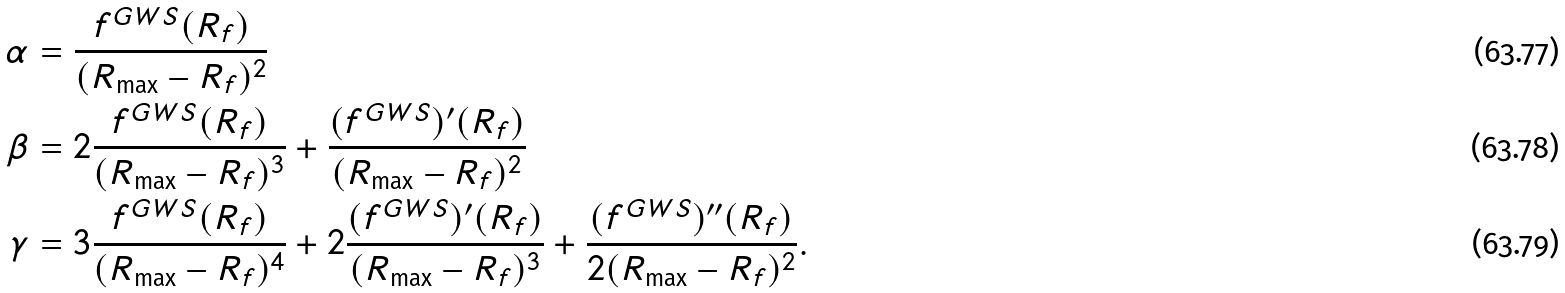Convert formula to latex. <formula><loc_0><loc_0><loc_500><loc_500>\alpha & = \frac { f ^ { G W S } ( R _ { f } ) } { ( R _ { \max } - R _ { f } ) ^ { 2 } } \\ \beta & = 2 \frac { f ^ { G W S } ( R _ { f } ) } { ( R _ { \max } - R _ { f } ) ^ { 3 } } + \frac { ( f ^ { G W S } ) ^ { \prime } ( R _ { f } ) } { ( R _ { \max } - R _ { f } ) ^ { 2 } } \\ \gamma & = 3 \frac { f ^ { G W S } ( R _ { f } ) } { ( R _ { \max } - R _ { f } ) ^ { 4 } } + 2 \frac { ( f ^ { G W S } ) ^ { \prime } ( R _ { f } ) } { ( R _ { \max } - R _ { f } ) ^ { 3 } } + \frac { ( f ^ { G W S } ) ^ { \prime \prime } ( R _ { f } ) } { 2 ( R _ { \max } - R _ { f } ) ^ { 2 } } .</formula> 